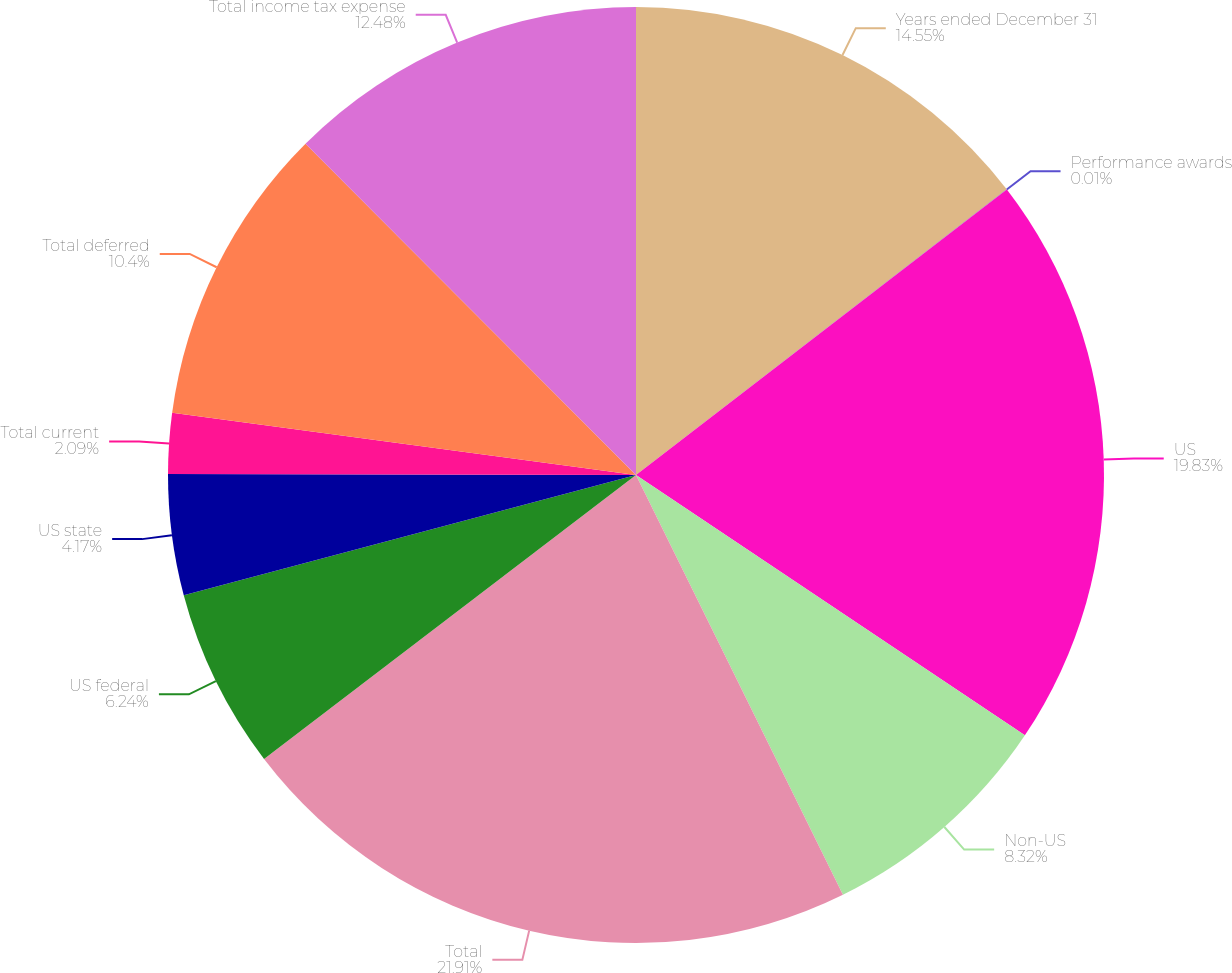Convert chart. <chart><loc_0><loc_0><loc_500><loc_500><pie_chart><fcel>Years ended December 31<fcel>Performance awards<fcel>US<fcel>Non-US<fcel>Total<fcel>US federal<fcel>US state<fcel>Total current<fcel>Total deferred<fcel>Total income tax expense<nl><fcel>14.55%<fcel>0.01%<fcel>19.83%<fcel>8.32%<fcel>21.91%<fcel>6.24%<fcel>4.17%<fcel>2.09%<fcel>10.4%<fcel>12.48%<nl></chart> 